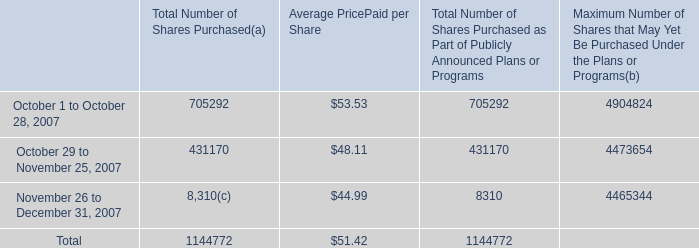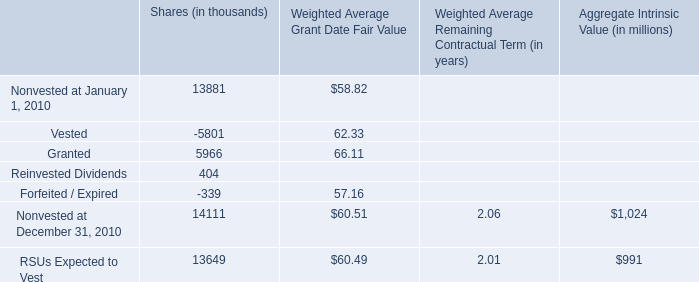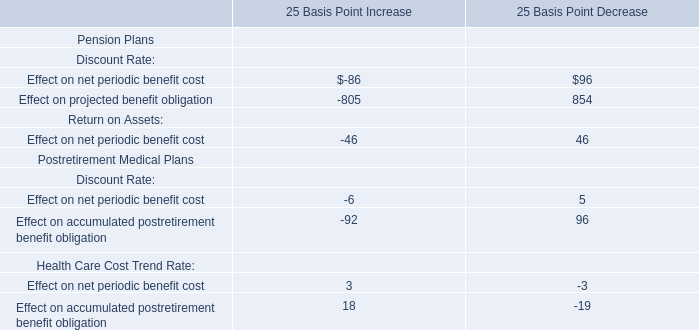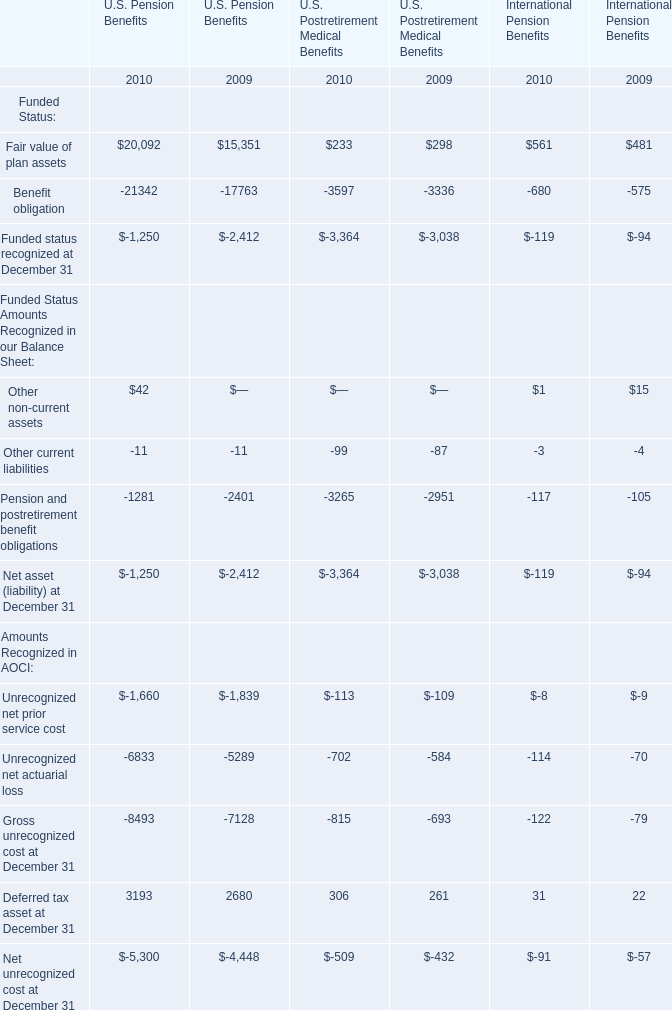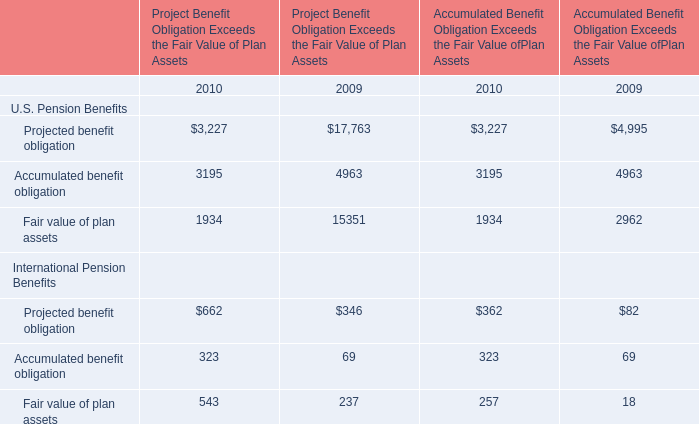what is the total amount of cash outflow used for shares repurchased during november 2007 , in millions? 
Computations: ((431170 * 48.11) / 1000000)
Answer: 20.74359. 